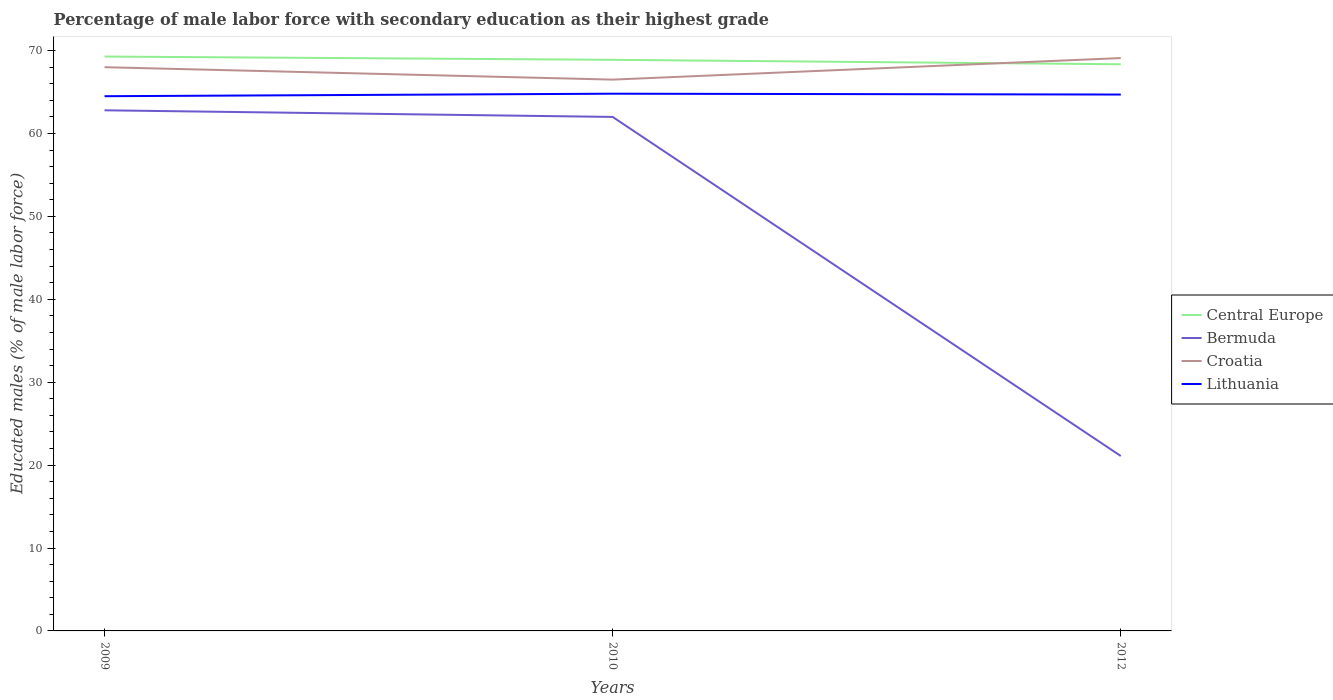How many different coloured lines are there?
Provide a succinct answer. 4. Does the line corresponding to Central Europe intersect with the line corresponding to Lithuania?
Your response must be concise. No. Is the number of lines equal to the number of legend labels?
Ensure brevity in your answer.  Yes. Across all years, what is the maximum percentage of male labor force with secondary education in Bermuda?
Give a very brief answer. 21.1. In which year was the percentage of male labor force with secondary education in Central Europe maximum?
Keep it short and to the point. 2012. What is the total percentage of male labor force with secondary education in Bermuda in the graph?
Offer a very short reply. 41.7. What is the difference between the highest and the second highest percentage of male labor force with secondary education in Lithuania?
Your answer should be compact. 0.3. Is the percentage of male labor force with secondary education in Lithuania strictly greater than the percentage of male labor force with secondary education in Central Europe over the years?
Your answer should be compact. Yes. How many lines are there?
Make the answer very short. 4. How many years are there in the graph?
Offer a terse response. 3. What is the difference between two consecutive major ticks on the Y-axis?
Ensure brevity in your answer.  10. Does the graph contain any zero values?
Your answer should be very brief. No. Does the graph contain grids?
Offer a terse response. No. Where does the legend appear in the graph?
Offer a very short reply. Center right. How many legend labels are there?
Make the answer very short. 4. How are the legend labels stacked?
Keep it short and to the point. Vertical. What is the title of the graph?
Your answer should be compact. Percentage of male labor force with secondary education as their highest grade. Does "Norway" appear as one of the legend labels in the graph?
Offer a terse response. No. What is the label or title of the X-axis?
Ensure brevity in your answer.  Years. What is the label or title of the Y-axis?
Provide a succinct answer. Educated males (% of male labor force). What is the Educated males (% of male labor force) of Central Europe in 2009?
Your response must be concise. 69.28. What is the Educated males (% of male labor force) of Bermuda in 2009?
Offer a very short reply. 62.8. What is the Educated males (% of male labor force) of Lithuania in 2009?
Offer a very short reply. 64.5. What is the Educated males (% of male labor force) in Central Europe in 2010?
Offer a very short reply. 68.89. What is the Educated males (% of male labor force) in Croatia in 2010?
Give a very brief answer. 66.5. What is the Educated males (% of male labor force) of Lithuania in 2010?
Ensure brevity in your answer.  64.8. What is the Educated males (% of male labor force) in Central Europe in 2012?
Provide a short and direct response. 68.35. What is the Educated males (% of male labor force) of Bermuda in 2012?
Your answer should be compact. 21.1. What is the Educated males (% of male labor force) of Croatia in 2012?
Offer a terse response. 69.1. What is the Educated males (% of male labor force) in Lithuania in 2012?
Offer a terse response. 64.7. Across all years, what is the maximum Educated males (% of male labor force) of Central Europe?
Your response must be concise. 69.28. Across all years, what is the maximum Educated males (% of male labor force) of Bermuda?
Ensure brevity in your answer.  62.8. Across all years, what is the maximum Educated males (% of male labor force) in Croatia?
Keep it short and to the point. 69.1. Across all years, what is the maximum Educated males (% of male labor force) of Lithuania?
Offer a very short reply. 64.8. Across all years, what is the minimum Educated males (% of male labor force) in Central Europe?
Your answer should be compact. 68.35. Across all years, what is the minimum Educated males (% of male labor force) of Bermuda?
Give a very brief answer. 21.1. Across all years, what is the minimum Educated males (% of male labor force) of Croatia?
Your answer should be very brief. 66.5. Across all years, what is the minimum Educated males (% of male labor force) in Lithuania?
Ensure brevity in your answer.  64.5. What is the total Educated males (% of male labor force) in Central Europe in the graph?
Provide a succinct answer. 206.52. What is the total Educated males (% of male labor force) in Bermuda in the graph?
Ensure brevity in your answer.  145.9. What is the total Educated males (% of male labor force) in Croatia in the graph?
Give a very brief answer. 203.6. What is the total Educated males (% of male labor force) in Lithuania in the graph?
Offer a terse response. 194. What is the difference between the Educated males (% of male labor force) of Central Europe in 2009 and that in 2010?
Your answer should be very brief. 0.39. What is the difference between the Educated males (% of male labor force) in Croatia in 2009 and that in 2010?
Your response must be concise. 1.5. What is the difference between the Educated males (% of male labor force) of Central Europe in 2009 and that in 2012?
Ensure brevity in your answer.  0.93. What is the difference between the Educated males (% of male labor force) in Bermuda in 2009 and that in 2012?
Provide a short and direct response. 41.7. What is the difference between the Educated males (% of male labor force) of Lithuania in 2009 and that in 2012?
Ensure brevity in your answer.  -0.2. What is the difference between the Educated males (% of male labor force) in Central Europe in 2010 and that in 2012?
Provide a succinct answer. 0.54. What is the difference between the Educated males (% of male labor force) in Bermuda in 2010 and that in 2012?
Provide a succinct answer. 40.9. What is the difference between the Educated males (% of male labor force) in Lithuania in 2010 and that in 2012?
Your response must be concise. 0.1. What is the difference between the Educated males (% of male labor force) in Central Europe in 2009 and the Educated males (% of male labor force) in Bermuda in 2010?
Keep it short and to the point. 7.28. What is the difference between the Educated males (% of male labor force) in Central Europe in 2009 and the Educated males (% of male labor force) in Croatia in 2010?
Make the answer very short. 2.78. What is the difference between the Educated males (% of male labor force) of Central Europe in 2009 and the Educated males (% of male labor force) of Lithuania in 2010?
Give a very brief answer. 4.48. What is the difference between the Educated males (% of male labor force) of Bermuda in 2009 and the Educated males (% of male labor force) of Lithuania in 2010?
Ensure brevity in your answer.  -2. What is the difference between the Educated males (% of male labor force) of Croatia in 2009 and the Educated males (% of male labor force) of Lithuania in 2010?
Offer a terse response. 3.2. What is the difference between the Educated males (% of male labor force) of Central Europe in 2009 and the Educated males (% of male labor force) of Bermuda in 2012?
Offer a very short reply. 48.18. What is the difference between the Educated males (% of male labor force) of Central Europe in 2009 and the Educated males (% of male labor force) of Croatia in 2012?
Offer a very short reply. 0.18. What is the difference between the Educated males (% of male labor force) in Central Europe in 2009 and the Educated males (% of male labor force) in Lithuania in 2012?
Give a very brief answer. 4.58. What is the difference between the Educated males (% of male labor force) in Bermuda in 2009 and the Educated males (% of male labor force) in Lithuania in 2012?
Your answer should be compact. -1.9. What is the difference between the Educated males (% of male labor force) of Croatia in 2009 and the Educated males (% of male labor force) of Lithuania in 2012?
Your answer should be very brief. 3.3. What is the difference between the Educated males (% of male labor force) in Central Europe in 2010 and the Educated males (% of male labor force) in Bermuda in 2012?
Make the answer very short. 47.79. What is the difference between the Educated males (% of male labor force) in Central Europe in 2010 and the Educated males (% of male labor force) in Croatia in 2012?
Offer a terse response. -0.21. What is the difference between the Educated males (% of male labor force) in Central Europe in 2010 and the Educated males (% of male labor force) in Lithuania in 2012?
Give a very brief answer. 4.19. What is the difference between the Educated males (% of male labor force) in Bermuda in 2010 and the Educated males (% of male labor force) in Croatia in 2012?
Your answer should be very brief. -7.1. What is the difference between the Educated males (% of male labor force) of Bermuda in 2010 and the Educated males (% of male labor force) of Lithuania in 2012?
Make the answer very short. -2.7. What is the difference between the Educated males (% of male labor force) of Croatia in 2010 and the Educated males (% of male labor force) of Lithuania in 2012?
Provide a succinct answer. 1.8. What is the average Educated males (% of male labor force) in Central Europe per year?
Ensure brevity in your answer.  68.84. What is the average Educated males (% of male labor force) of Bermuda per year?
Provide a short and direct response. 48.63. What is the average Educated males (% of male labor force) in Croatia per year?
Offer a terse response. 67.87. What is the average Educated males (% of male labor force) in Lithuania per year?
Your answer should be compact. 64.67. In the year 2009, what is the difference between the Educated males (% of male labor force) in Central Europe and Educated males (% of male labor force) in Bermuda?
Your answer should be very brief. 6.48. In the year 2009, what is the difference between the Educated males (% of male labor force) in Central Europe and Educated males (% of male labor force) in Croatia?
Keep it short and to the point. 1.28. In the year 2009, what is the difference between the Educated males (% of male labor force) of Central Europe and Educated males (% of male labor force) of Lithuania?
Offer a very short reply. 4.78. In the year 2009, what is the difference between the Educated males (% of male labor force) in Bermuda and Educated males (% of male labor force) in Lithuania?
Offer a terse response. -1.7. In the year 2009, what is the difference between the Educated males (% of male labor force) of Croatia and Educated males (% of male labor force) of Lithuania?
Keep it short and to the point. 3.5. In the year 2010, what is the difference between the Educated males (% of male labor force) in Central Europe and Educated males (% of male labor force) in Bermuda?
Give a very brief answer. 6.89. In the year 2010, what is the difference between the Educated males (% of male labor force) in Central Europe and Educated males (% of male labor force) in Croatia?
Provide a succinct answer. 2.39. In the year 2010, what is the difference between the Educated males (% of male labor force) in Central Europe and Educated males (% of male labor force) in Lithuania?
Your answer should be compact. 4.09. In the year 2010, what is the difference between the Educated males (% of male labor force) in Bermuda and Educated males (% of male labor force) in Croatia?
Your response must be concise. -4.5. In the year 2012, what is the difference between the Educated males (% of male labor force) in Central Europe and Educated males (% of male labor force) in Bermuda?
Give a very brief answer. 47.25. In the year 2012, what is the difference between the Educated males (% of male labor force) of Central Europe and Educated males (% of male labor force) of Croatia?
Offer a very short reply. -0.75. In the year 2012, what is the difference between the Educated males (% of male labor force) in Central Europe and Educated males (% of male labor force) in Lithuania?
Ensure brevity in your answer.  3.65. In the year 2012, what is the difference between the Educated males (% of male labor force) in Bermuda and Educated males (% of male labor force) in Croatia?
Give a very brief answer. -48. In the year 2012, what is the difference between the Educated males (% of male labor force) in Bermuda and Educated males (% of male labor force) in Lithuania?
Make the answer very short. -43.6. What is the ratio of the Educated males (% of male labor force) of Central Europe in 2009 to that in 2010?
Your response must be concise. 1.01. What is the ratio of the Educated males (% of male labor force) of Bermuda in 2009 to that in 2010?
Offer a terse response. 1.01. What is the ratio of the Educated males (% of male labor force) of Croatia in 2009 to that in 2010?
Provide a short and direct response. 1.02. What is the ratio of the Educated males (% of male labor force) in Lithuania in 2009 to that in 2010?
Ensure brevity in your answer.  1. What is the ratio of the Educated males (% of male labor force) in Central Europe in 2009 to that in 2012?
Keep it short and to the point. 1.01. What is the ratio of the Educated males (% of male labor force) of Bermuda in 2009 to that in 2012?
Give a very brief answer. 2.98. What is the ratio of the Educated males (% of male labor force) in Croatia in 2009 to that in 2012?
Make the answer very short. 0.98. What is the ratio of the Educated males (% of male labor force) in Central Europe in 2010 to that in 2012?
Provide a succinct answer. 1.01. What is the ratio of the Educated males (% of male labor force) of Bermuda in 2010 to that in 2012?
Your answer should be compact. 2.94. What is the ratio of the Educated males (% of male labor force) in Croatia in 2010 to that in 2012?
Provide a succinct answer. 0.96. What is the ratio of the Educated males (% of male labor force) in Lithuania in 2010 to that in 2012?
Ensure brevity in your answer.  1. What is the difference between the highest and the second highest Educated males (% of male labor force) of Central Europe?
Keep it short and to the point. 0.39. What is the difference between the highest and the second highest Educated males (% of male labor force) of Bermuda?
Keep it short and to the point. 0.8. What is the difference between the highest and the second highest Educated males (% of male labor force) in Croatia?
Ensure brevity in your answer.  1.1. What is the difference between the highest and the lowest Educated males (% of male labor force) of Central Europe?
Keep it short and to the point. 0.93. What is the difference between the highest and the lowest Educated males (% of male labor force) in Bermuda?
Offer a very short reply. 41.7. 